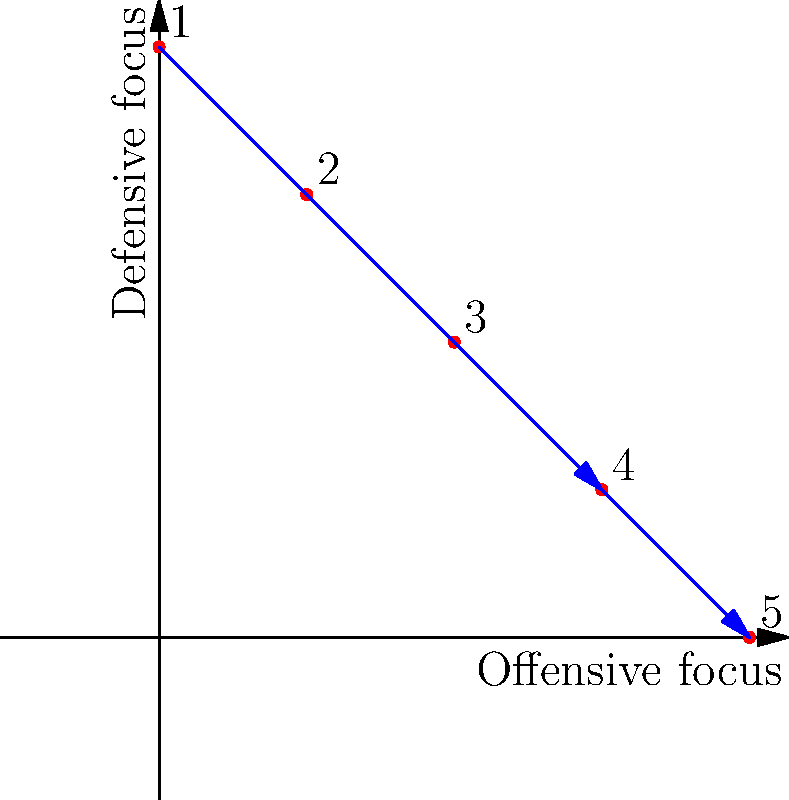Consider a team rotation strategy represented by the group action of $S_5$ on the set of 5 different offensive-defensive focus combinations. The diagram shows these combinations plotted on a 2D plane, where the x-axis represents offensive focus and the y-axis represents defensive focus. A particular permutation $\sigma \in S_5$ is illustrated by the blue arrows.

What is the cycle structure of $\sigma$, and how many fixed points does it have? To determine the cycle structure and fixed points of the permutation $\sigma$, let's follow these steps:

1) Analyze the blue arrows in the diagram:
   - Point 1 maps to Point 5
   - Point 5 maps to Point 1
   - Point 2 maps to Point 4
   - Point 4 maps to Point 2
   - Point 3 maps to itself

2) From this, we can write $\sigma$ in cycle notation:
   $\sigma = (1 5)(2 4)(3)$

3) The cycle structure of $\sigma$ is:
   - One 2-cycle: (1 5)
   - One 2-cycle: (2 4)
   - One 1-cycle: (3)

4) Count the number of cycles:
   - Two 2-cycles
   - One 1-cycle

5) Identify fixed points:
   A fixed point is any element that maps to itself. In cycle notation, these are the 1-cycles.
   The only 1-cycle is (3), so there is 1 fixed point.

Therefore, the cycle structure of $\sigma$ is $[2,2,1]$, and it has 1 fixed point.
Answer: Cycle structure: $[2,2,1]$, 1 fixed point 